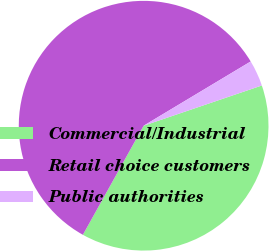<chart> <loc_0><loc_0><loc_500><loc_500><pie_chart><fcel>Commercial/Industrial<fcel>Retail choice customers<fcel>Public authorities<nl><fcel>38.31%<fcel>58.31%<fcel>3.38%<nl></chart> 